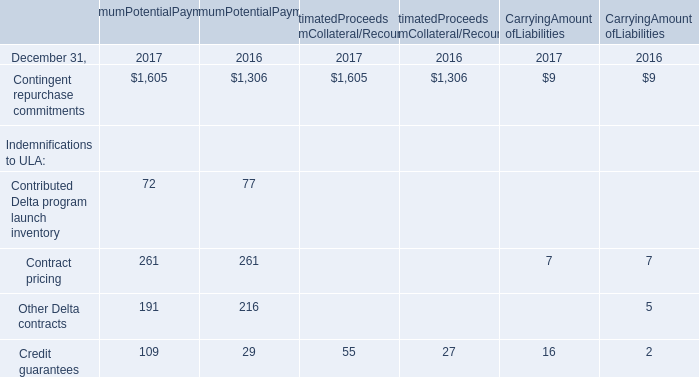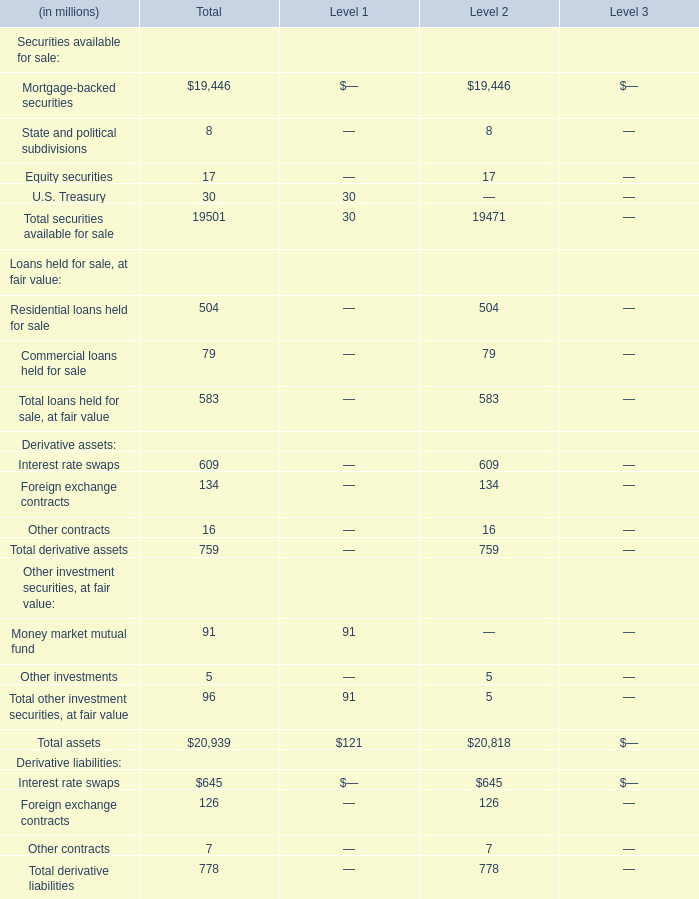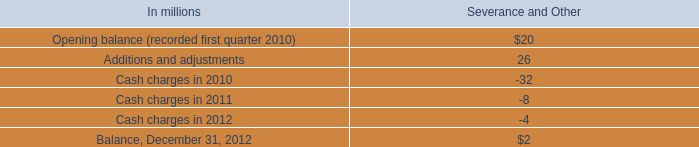What was the total amount of Securities available for sale in the range of 10 million and 20000 million for Level 2? (in million) 
Computations: (19446 + 17)
Answer: 19463.0. 